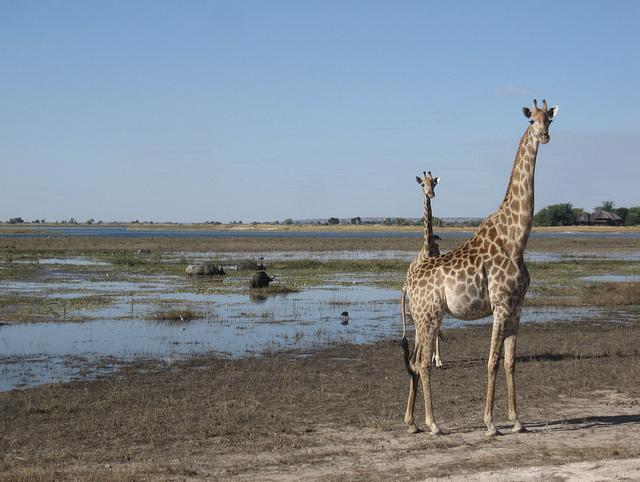The giraffe in the front is probably related to the one behind in what way?

Choices:
A) sibling
B) parent
C) partner
D) none parent 